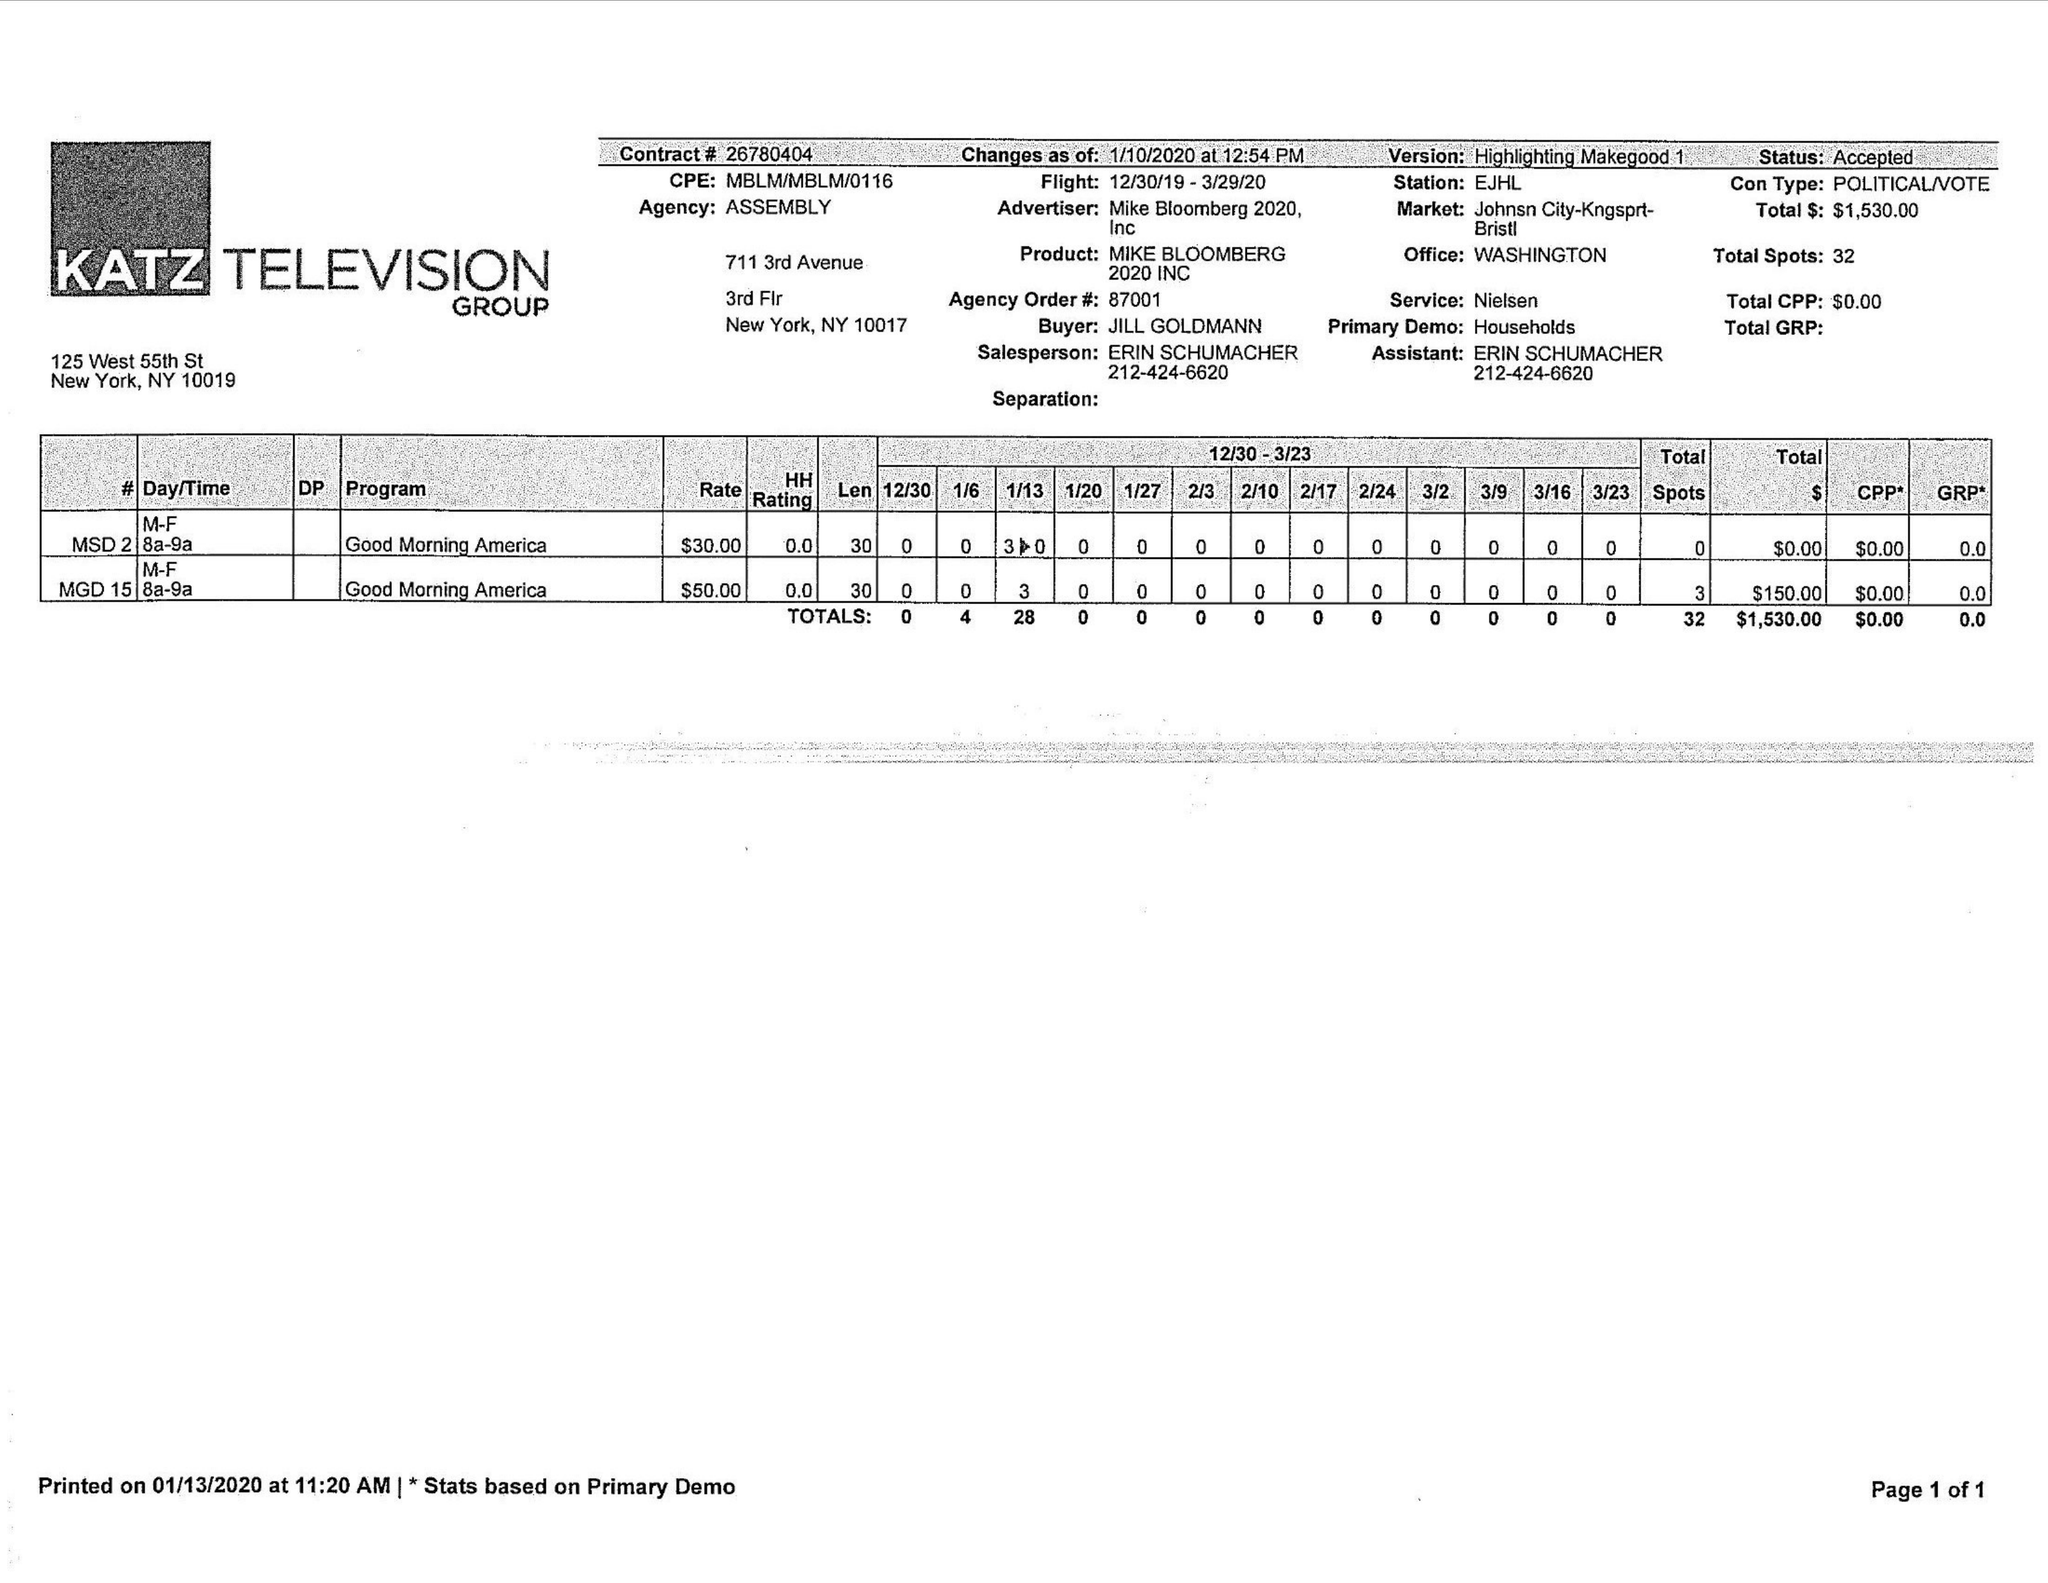What is the value for the flight_from?
Answer the question using a single word or phrase. 12/30/19 